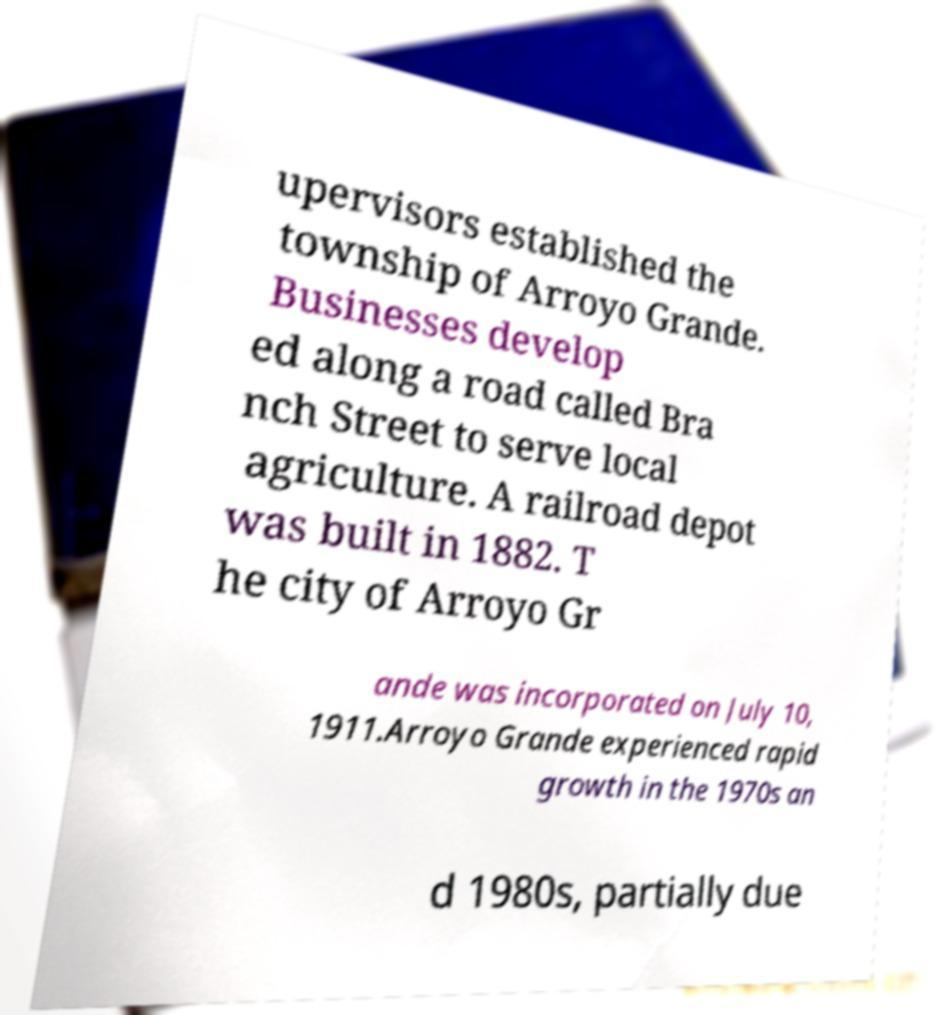I need the written content from this picture converted into text. Can you do that? upervisors established the township of Arroyo Grande. Businesses develop ed along a road called Bra nch Street to serve local agriculture. A railroad depot was built in 1882. T he city of Arroyo Gr ande was incorporated on July 10, 1911.Arroyo Grande experienced rapid growth in the 1970s an d 1980s, partially due 